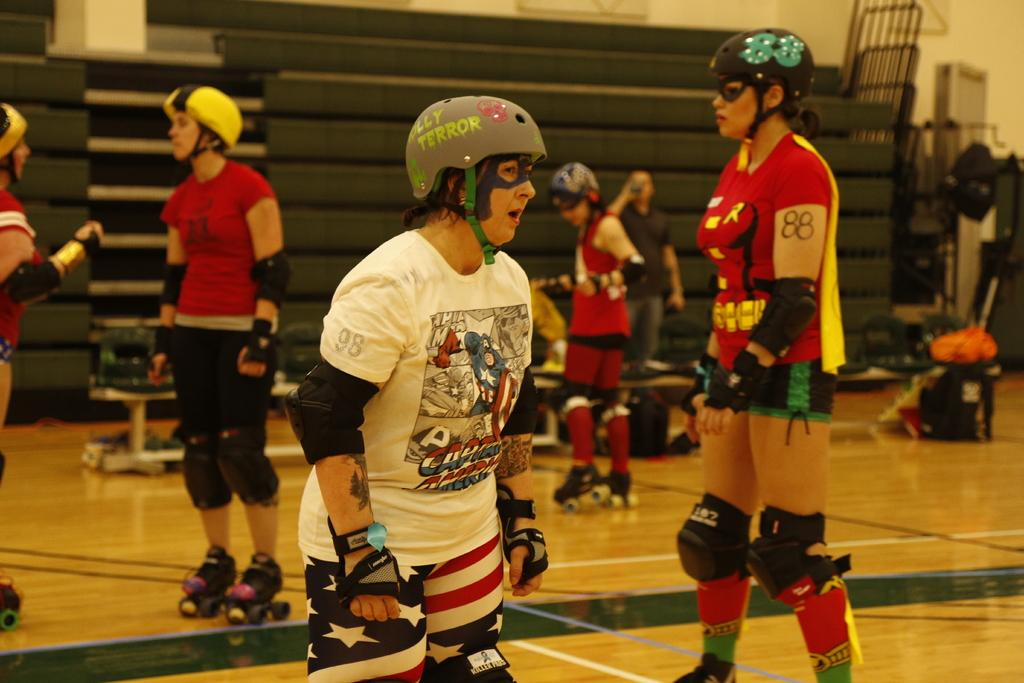How many people are in the image? There are people in the image, but the exact number is not specified. What type of protective gear is the person in front wearing? The person in front is wearing a helmet, gloves, and skate shoes. What can be seen on the table in the back? There are bags on a table in the back. What is visible in the background of the image? There is a wall visible in the image. What type of jeans is the judge wearing in the image? There is no judge or jeans present in the image. Is the volleyball being used by the people in the image? There is no volleyball present in the image. 